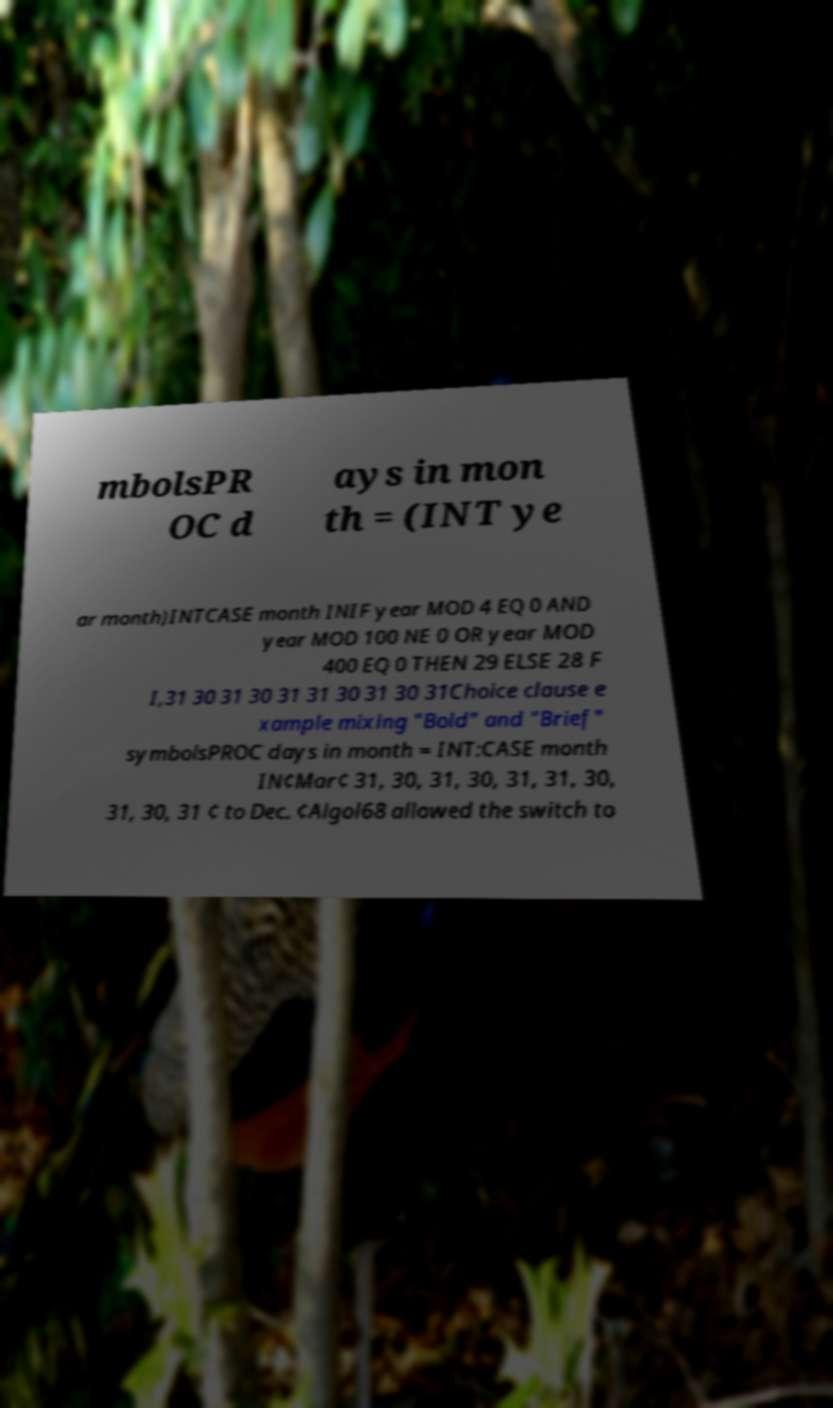What messages or text are displayed in this image? I need them in a readable, typed format. mbolsPR OC d ays in mon th = (INT ye ar month)INTCASE month INIF year MOD 4 EQ 0 AND year MOD 100 NE 0 OR year MOD 400 EQ 0 THEN 29 ELSE 28 F I,31 30 31 30 31 31 30 31 30 31Choice clause e xample mixing "Bold" and "Brief" symbolsPROC days in month = INT:CASE month IN¢Mar¢ 31, 30, 31, 30, 31, 31, 30, 31, 30, 31 ¢ to Dec. ¢Algol68 allowed the switch to 